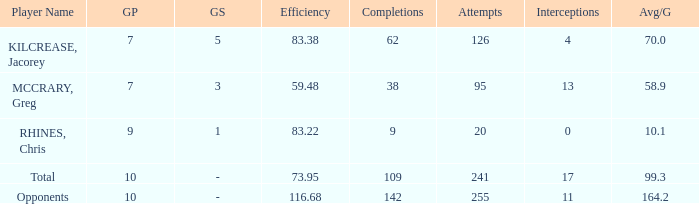What is the avg/g of Rhines, Chris, who has an effic greater than 73.95? 10.1. 